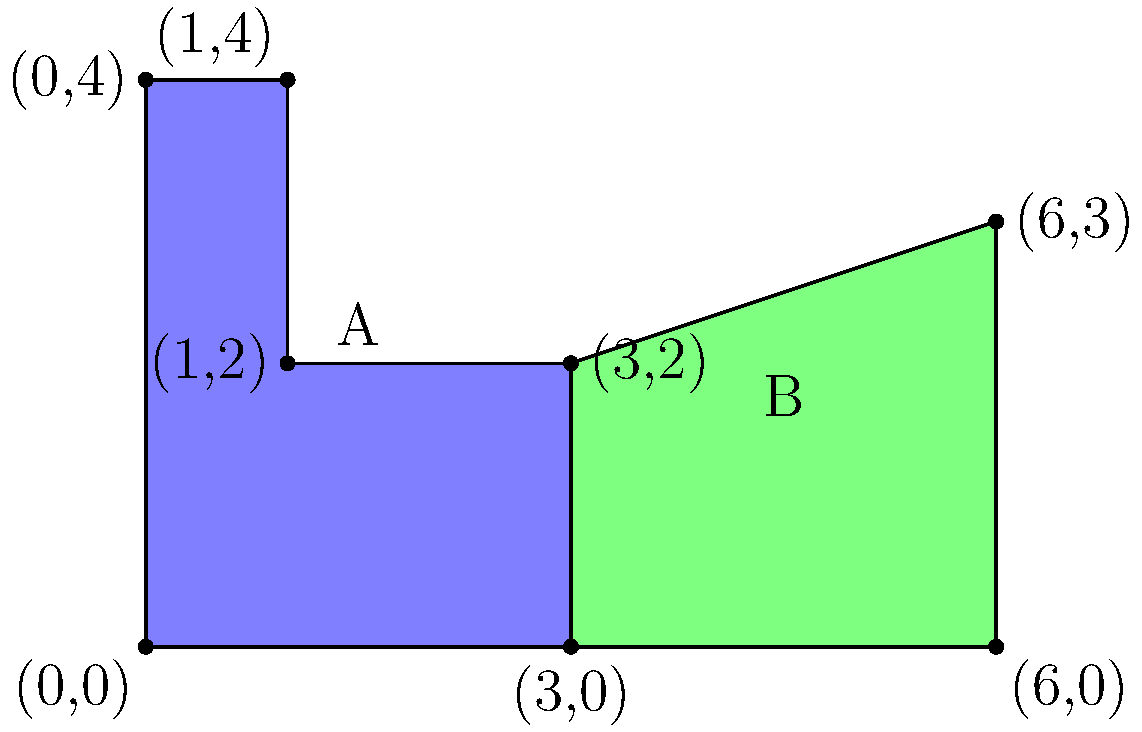As a legal representative for an industrial company, you're tasked with calculating the total area of two adjacent land parcels for a potential manufacturing unit. The land is irregularly shaped, as shown in the diagram. Parcel A (blue) is composed of a rectangle and a square, while Parcel B (green) is a trapezoid. Given the coordinates of the vertices, calculate the total area of both parcels combined in square units. To calculate the total area, we'll break down the problem into steps:

1. Calculate the area of Parcel A:
   a. Rectangle area: $3 \times 2 = 6$ sq units
   b. Square area: $1 \times 2 = 2$ sq units
   c. Total area of A: $6 + 2 = 8$ sq units

2. Calculate the area of Parcel B (trapezoid):
   Using the formula: $A = \frac{1}{2}(b_1 + b_2)h$
   where $b_1$ and $b_2$ are parallel sides, and $h$ is the height
   a. $b_1 = 3$ units (bottom side)
   b. $b_2 = 3$ units (top side)
   c. $h = 3$ units (height)
   d. Area of B: $\frac{1}{2}(3 + 3) \times 3 = 9$ sq units

3. Calculate the total area:
   Total area = Area of A + Area of B
               $= 8 + 9 = 17$ sq units

Therefore, the total area of both parcels combined is 17 square units.
Answer: 17 square units 